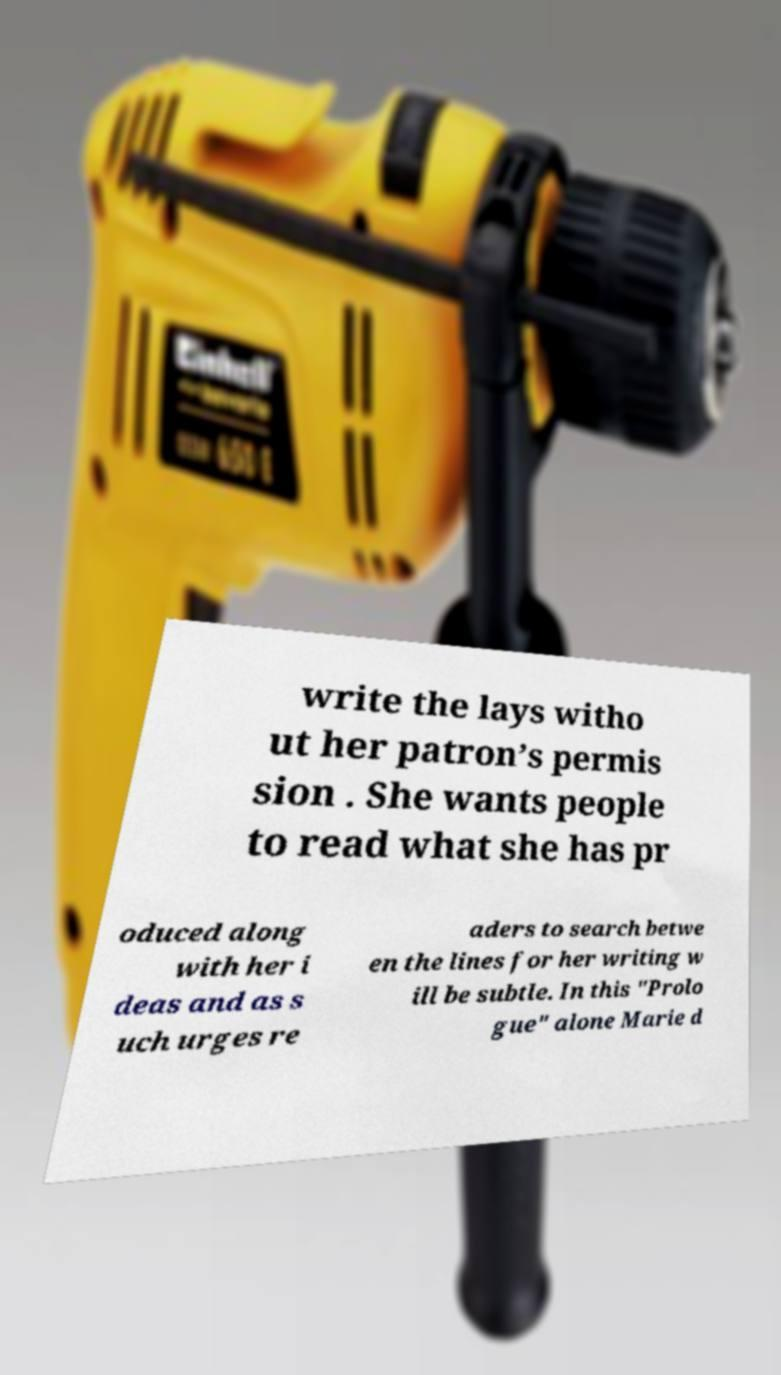Can you read and provide the text displayed in the image?This photo seems to have some interesting text. Can you extract and type it out for me? write the lays witho ut her patron’s permis sion . She wants people to read what she has pr oduced along with her i deas and as s uch urges re aders to search betwe en the lines for her writing w ill be subtle. In this "Prolo gue" alone Marie d 